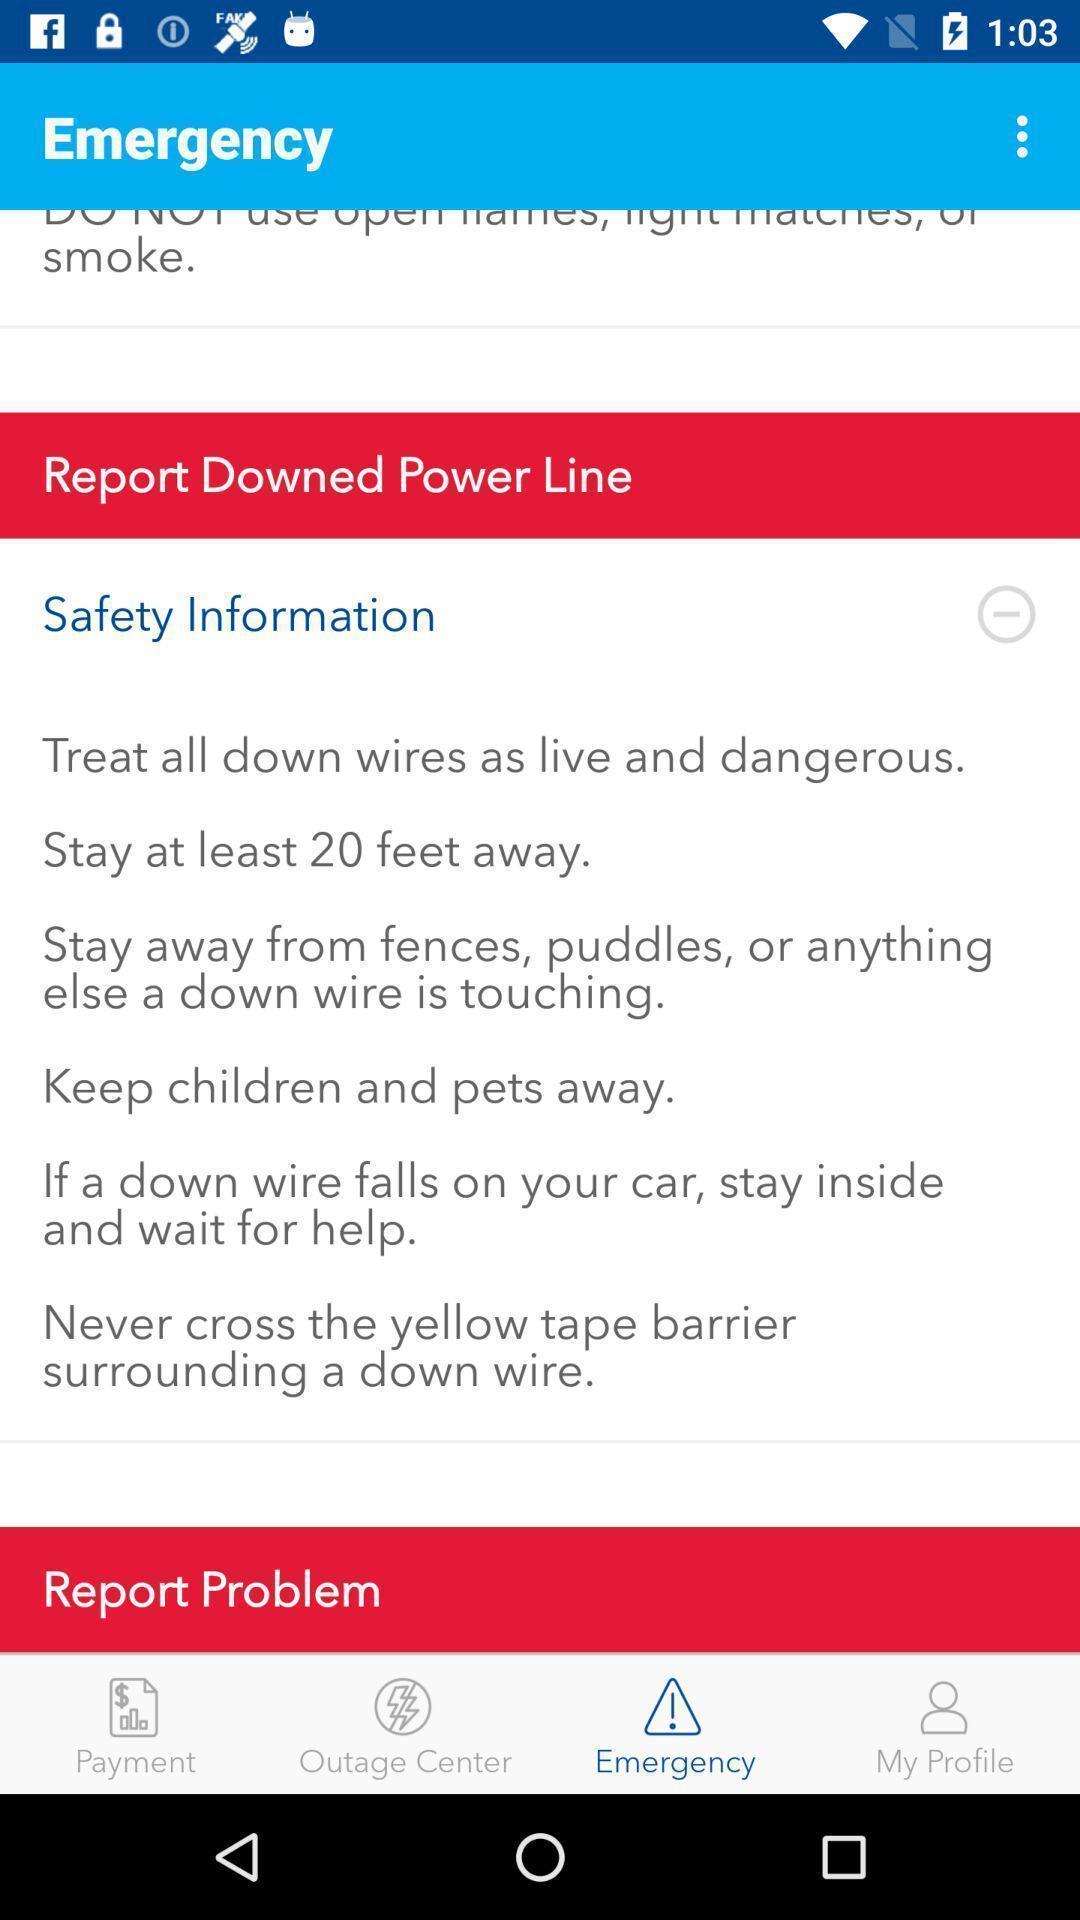Describe the key features of this screenshot. Screen shows multiple options. 